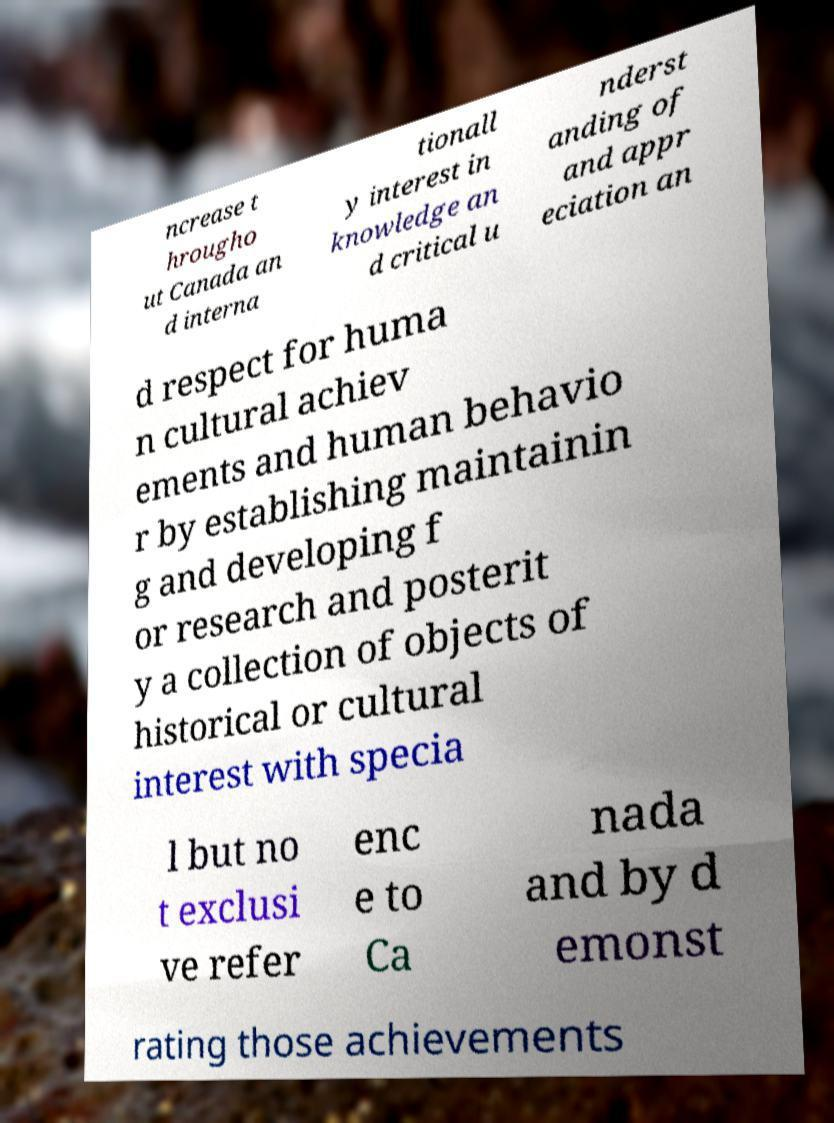Please read and relay the text visible in this image. What does it say? ncrease t hrougho ut Canada an d interna tionall y interest in knowledge an d critical u nderst anding of and appr eciation an d respect for huma n cultural achiev ements and human behavio r by establishing maintainin g and developing f or research and posterit y a collection of objects of historical or cultural interest with specia l but no t exclusi ve refer enc e to Ca nada and by d emonst rating those achievements 